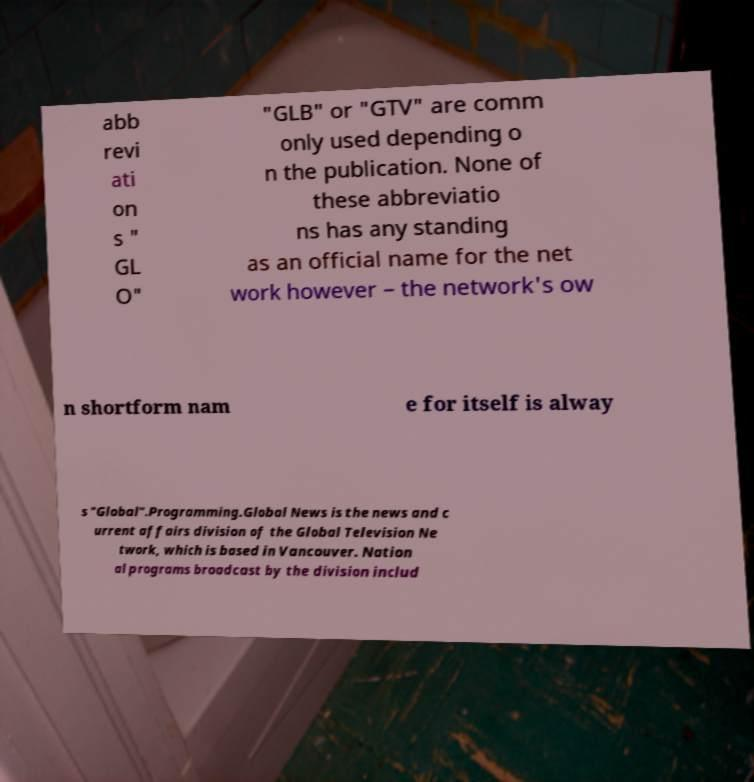Can you accurately transcribe the text from the provided image for me? abb revi ati on s " GL O" "GLB" or "GTV" are comm only used depending o n the publication. None of these abbreviatio ns has any standing as an official name for the net work however – the network's ow n shortform nam e for itself is alway s "Global".Programming.Global News is the news and c urrent affairs division of the Global Television Ne twork, which is based in Vancouver. Nation al programs broadcast by the division includ 